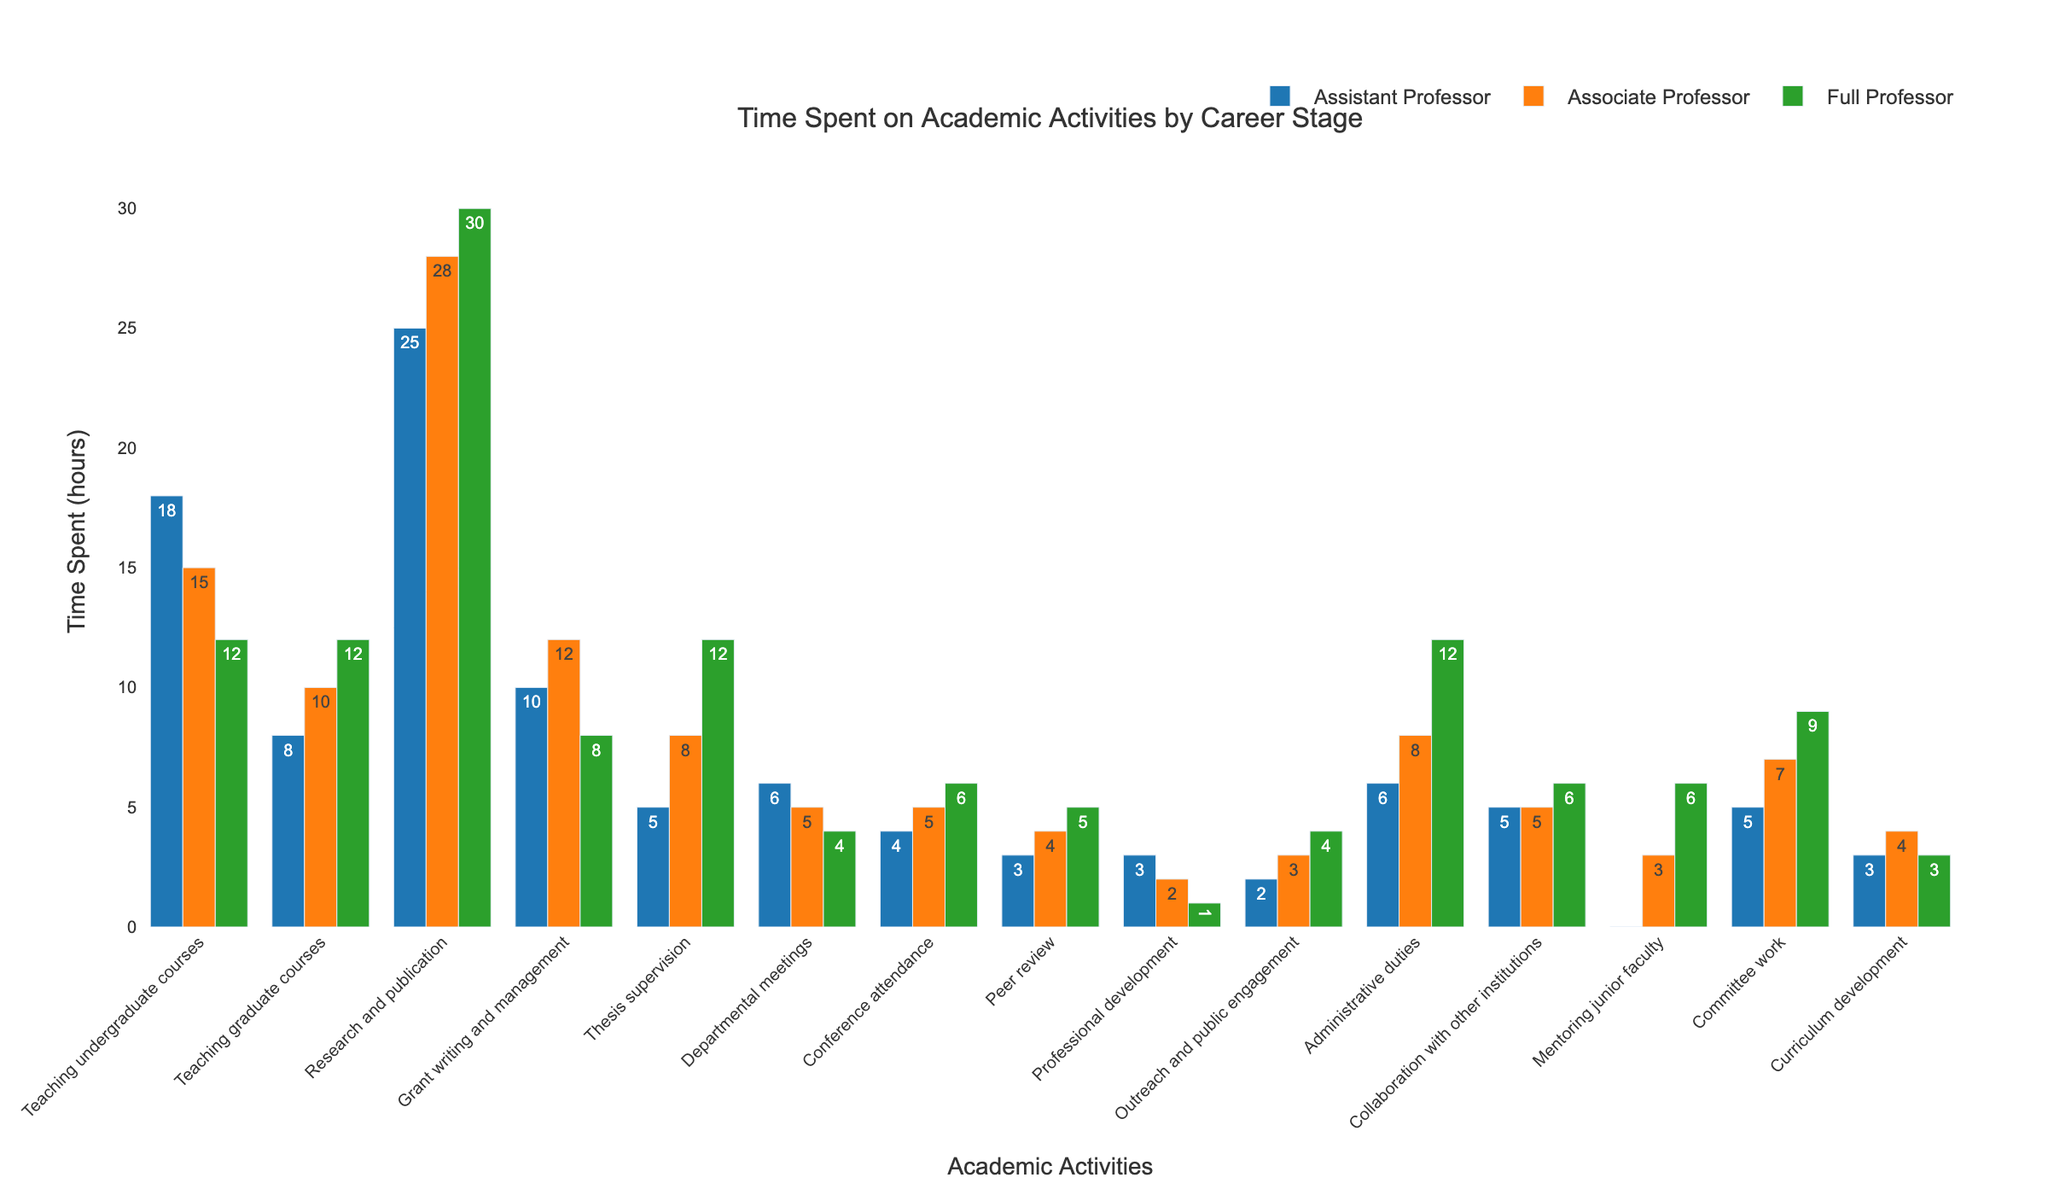What activity has the highest time spent for full professors? By observing the height of the bars for full professors, we find that the bar representing "Research and publication" is the tallest.
Answer: Research and publication Which activity has the least time spent by assistant professors? By looking at the shortest bar for assistant professors, we find that "Outreach and public engagement" and "Professional development" both have the same shortest bar height.
Answer: Professional development, Outreach and public engagement How much more time do full professors spend on thesis supervision compared to assistant professors? Full professors spend 12 hours on thesis supervision, while assistant professors spend 5 hours. The difference is 12 - 5.
Answer: 7 hours Compare the time spent on teaching undergraduate courses between assistant and full professors. Assistant professors spend 18 hours, while full professors spend 12 hours. Assistant professors spend more time on this activity.
Answer: Assistant professors spend more What is the total time spent on administrative duties by all career stages combined? Summing up the hours for assistant professor (6), associate professor (8), and full professor (12). The total is 6 + 8 + 12.
Answer: 26 hours Which activity has the most balanced time spent across all career stages? "Collaboration with other institutions" has the bars of similar height across all career stages (5 for assistant professors, 5 for associate professors, and 6 for full professors).
Answer: Collaboration with other institutions What is the difference in the average time spent on teaching activities (undergraduate and graduate) between associate and full professors? For associate professors, the times are 15 and 10, the average is (15+10)/2 = 12.5. For full professors, the times are 12 and 12, the average is 12. The difference is 12.5 - 12.
Answer: 0.5 hours Which two activities have the same time allocation for associate professors? By comparing the bar heights for associate professors, "Departmental meetings" and "Collaboration with other institutions" both have a value of 5 hours.
Answer: Departmental meetings, Collaboration with other institutions Among assistant professors, what is the combined time spent on departmental meetings and committee work? Summing the time spent on departmental meetings (6) and committee work (5) for assistant professors. 6 + 5
Answer: 11 hours 